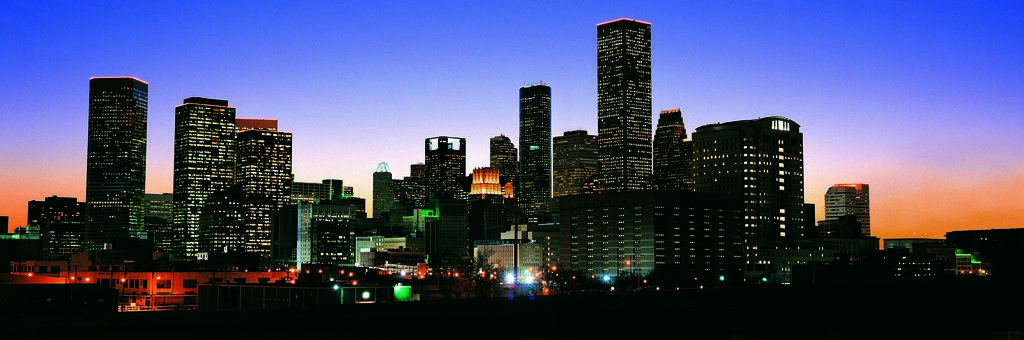What type of structures can be seen in the image? There are many buildings with lights in the image. What can be seen in the background of the image? The sky is visible in the background of the image. How many snails can be seen crawling on the buildings in the image? There are no snails present in the image; the focus is on the buildings with lights and the sky. 